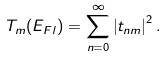<formula> <loc_0><loc_0><loc_500><loc_500>T _ { m } ( E _ { F l } ) = \sum _ { n = 0 } ^ { \infty } \left | t _ { n m } \right | ^ { 2 } .</formula> 